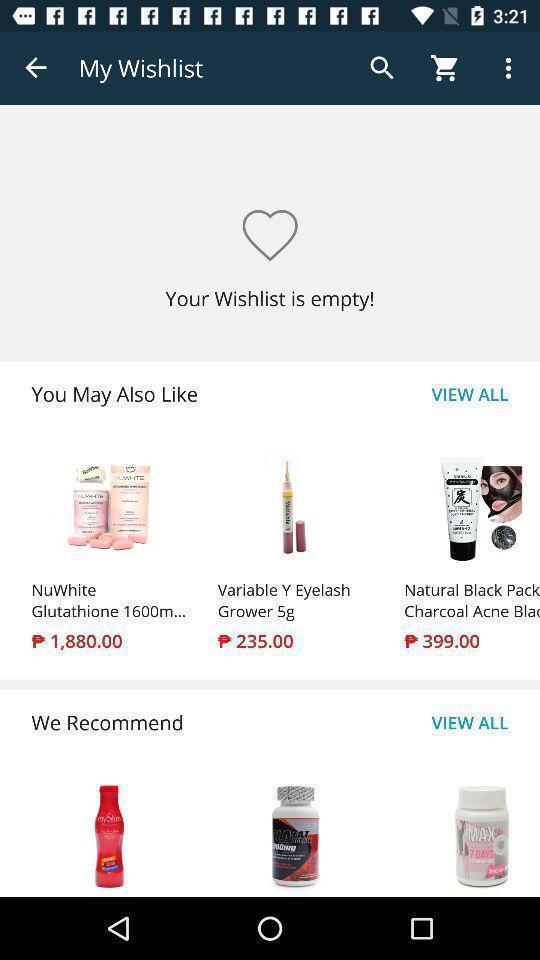Give me a summary of this screen capture. Screen showing page of an shopping application. 